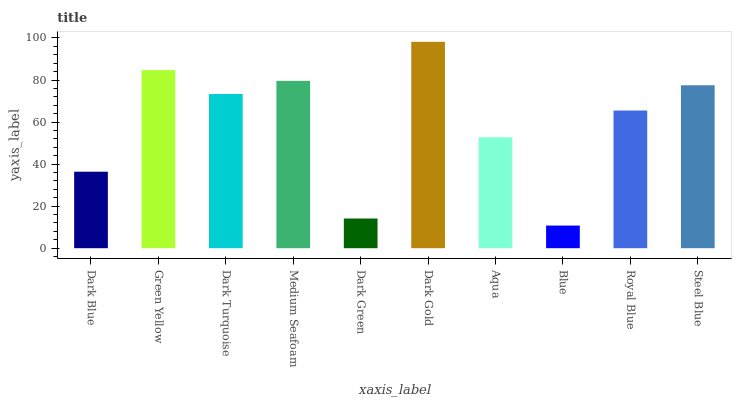Is Blue the minimum?
Answer yes or no. Yes. Is Dark Gold the maximum?
Answer yes or no. Yes. Is Green Yellow the minimum?
Answer yes or no. No. Is Green Yellow the maximum?
Answer yes or no. No. Is Green Yellow greater than Dark Blue?
Answer yes or no. Yes. Is Dark Blue less than Green Yellow?
Answer yes or no. Yes. Is Dark Blue greater than Green Yellow?
Answer yes or no. No. Is Green Yellow less than Dark Blue?
Answer yes or no. No. Is Dark Turquoise the high median?
Answer yes or no. Yes. Is Royal Blue the low median?
Answer yes or no. Yes. Is Green Yellow the high median?
Answer yes or no. No. Is Medium Seafoam the low median?
Answer yes or no. No. 